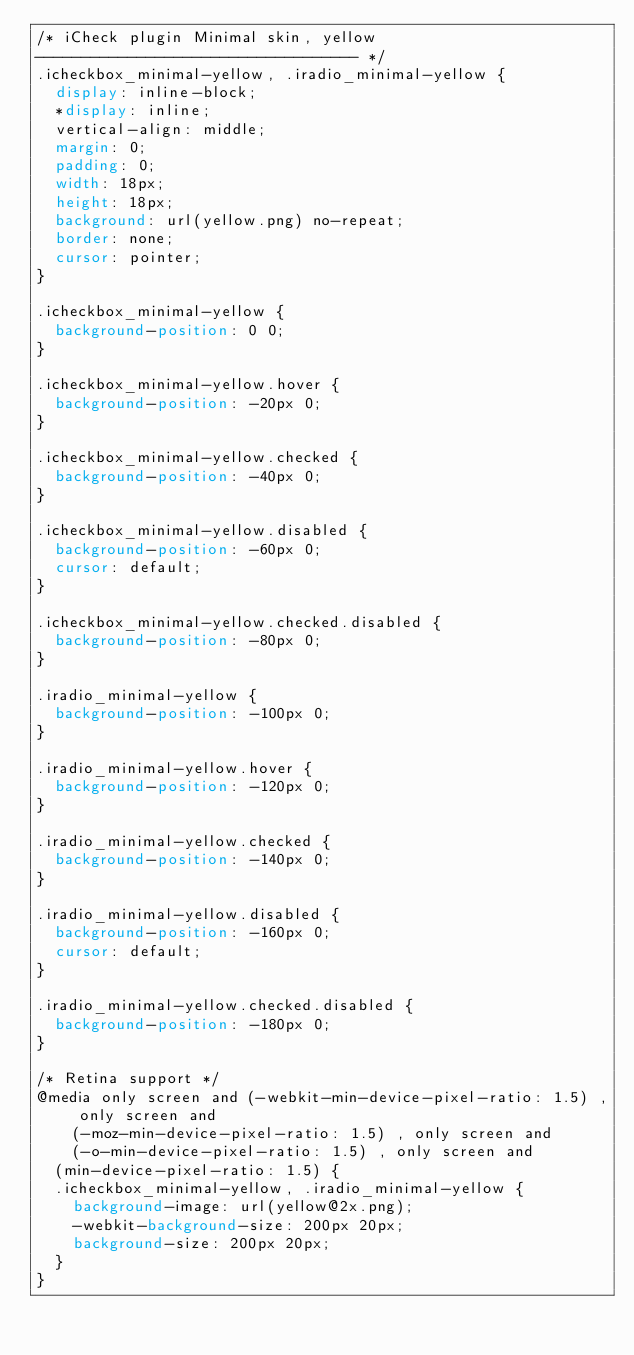Convert code to text. <code><loc_0><loc_0><loc_500><loc_500><_CSS_>/* iCheck plugin Minimal skin, yellow
----------------------------------- */
.icheckbox_minimal-yellow, .iradio_minimal-yellow {
	display: inline-block;
	*display: inline;
	vertical-align: middle;
	margin: 0;
	padding: 0;
	width: 18px;
	height: 18px;
	background: url(yellow.png) no-repeat;
	border: none;
	cursor: pointer;
}

.icheckbox_minimal-yellow {
	background-position: 0 0;
}

.icheckbox_minimal-yellow.hover {
	background-position: -20px 0;
}

.icheckbox_minimal-yellow.checked {
	background-position: -40px 0;
}

.icheckbox_minimal-yellow.disabled {
	background-position: -60px 0;
	cursor: default;
}

.icheckbox_minimal-yellow.checked.disabled {
	background-position: -80px 0;
}

.iradio_minimal-yellow {
	background-position: -100px 0;
}

.iradio_minimal-yellow.hover {
	background-position: -120px 0;
}

.iradio_minimal-yellow.checked {
	background-position: -140px 0;
}

.iradio_minimal-yellow.disabled {
	background-position: -160px 0;
	cursor: default;
}

.iradio_minimal-yellow.checked.disabled {
	background-position: -180px 0;
}

/* Retina support */
@media only screen and (-webkit-min-device-pixel-ratio: 1.5) , only screen and
		(-moz-min-device-pixel-ratio: 1.5) , only screen and
		(-o-min-device-pixel-ratio: 1.5) , only screen and
	(min-device-pixel-ratio: 1.5) {
	.icheckbox_minimal-yellow, .iradio_minimal-yellow {
		background-image: url(yellow@2x.png);
		-webkit-background-size: 200px 20px;
		background-size: 200px 20px;
	}
}</code> 